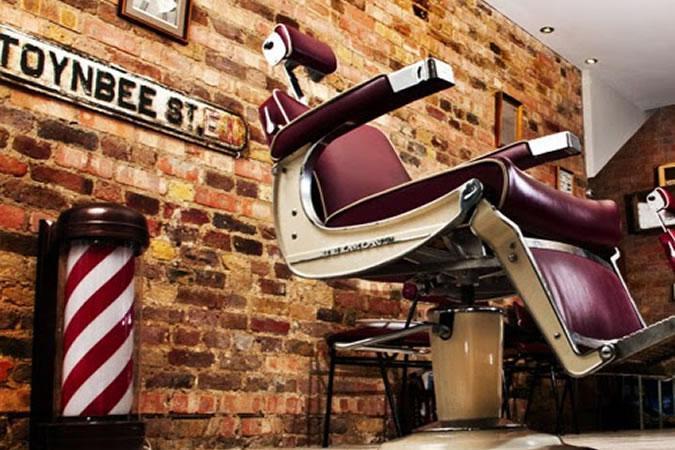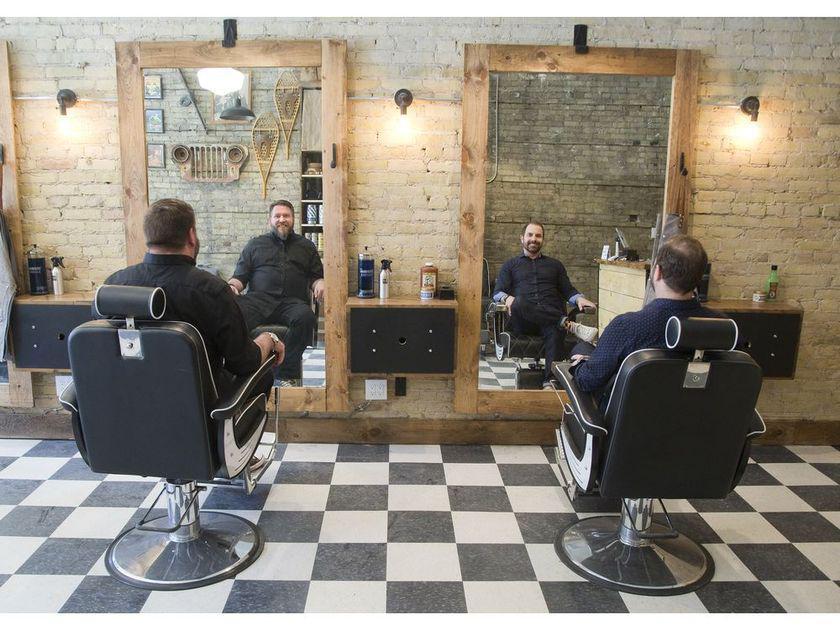The first image is the image on the left, the second image is the image on the right. Given the left and right images, does the statement "In at least one image there are a total of two black barber chairs." hold true? Answer yes or no. Yes. The first image is the image on the left, the second image is the image on the right. Analyze the images presented: Is the assertion "In one image, men sit with their backs to the camera in front of tall rectangular wood framed mirrors." valid? Answer yes or no. Yes. 